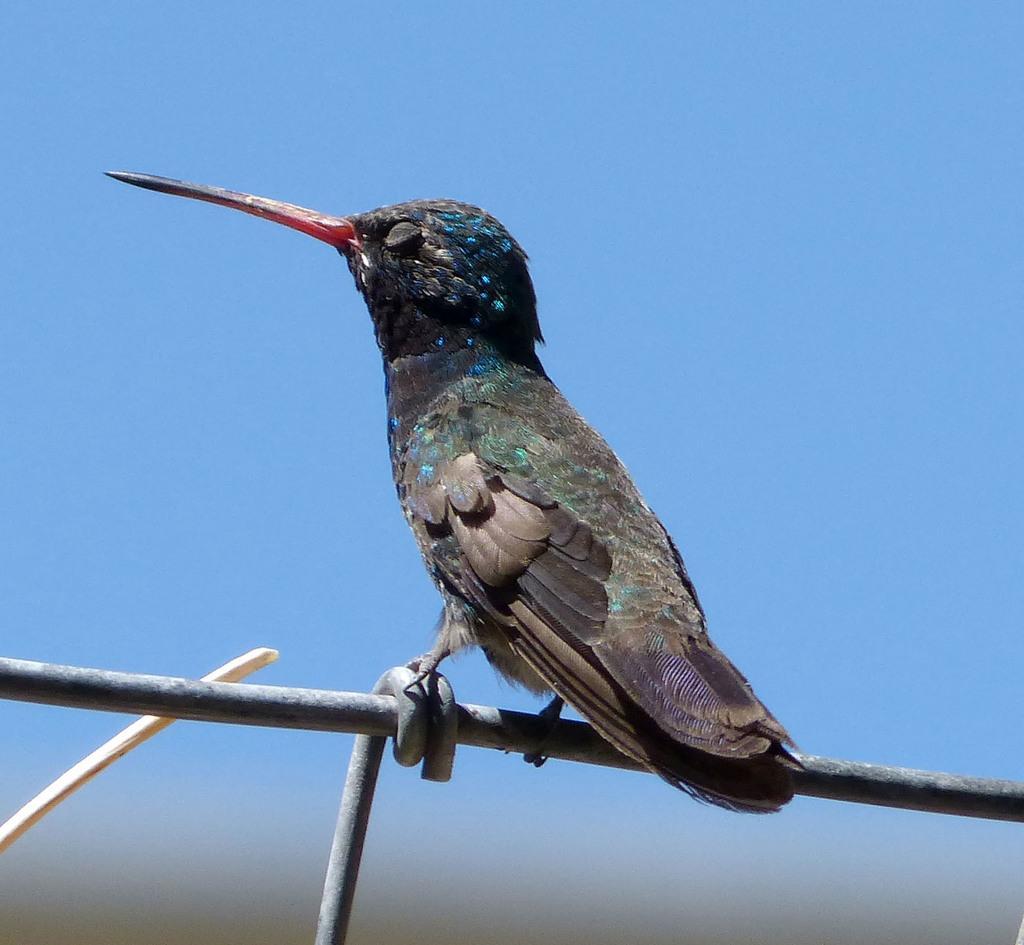Describe this image in one or two sentences. In this image In the front there is a bird standing on the rod and there is an object which is white in colour. 